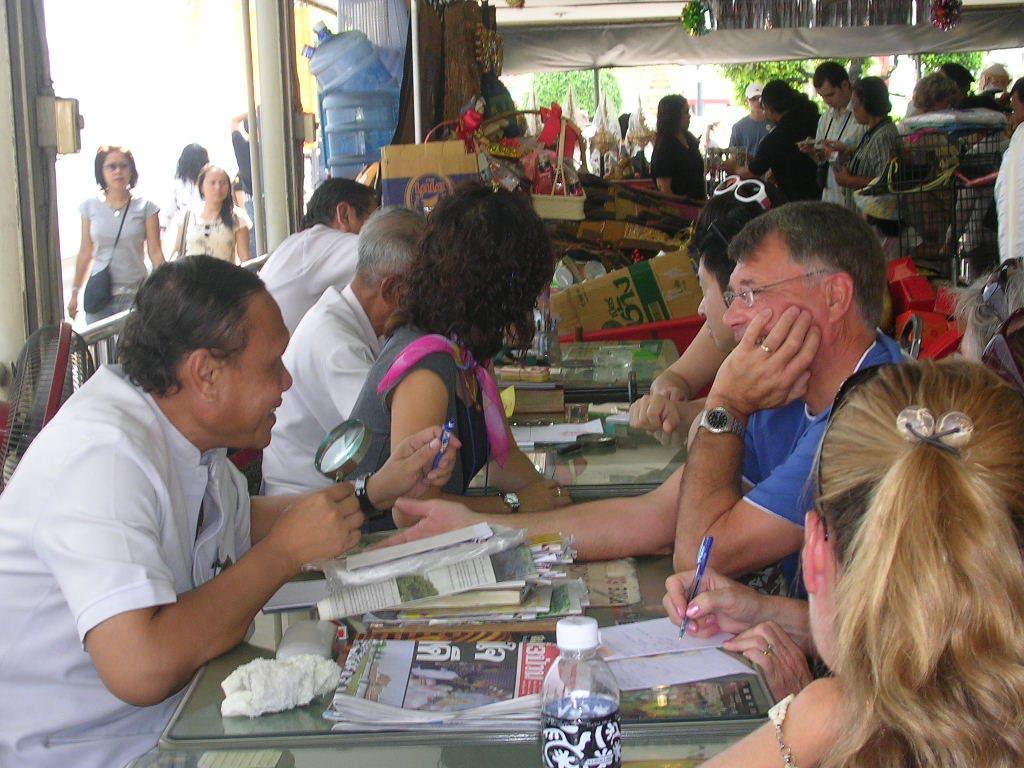Please provide a concise description of this image. In this image there are a few people sitting on chairs, in front of them on the table there is a bottle of water, papers, books, pens and some other objects, one of the person is holding a magnifier glass in his hand and holding a pen in his other hand, in front of him there is another person writing with a pen on a paper, behind them there are a few other people standing and there are a few other objects and stuff, behind them there are a few people walking on the streets, in the background of the image there are trees. 